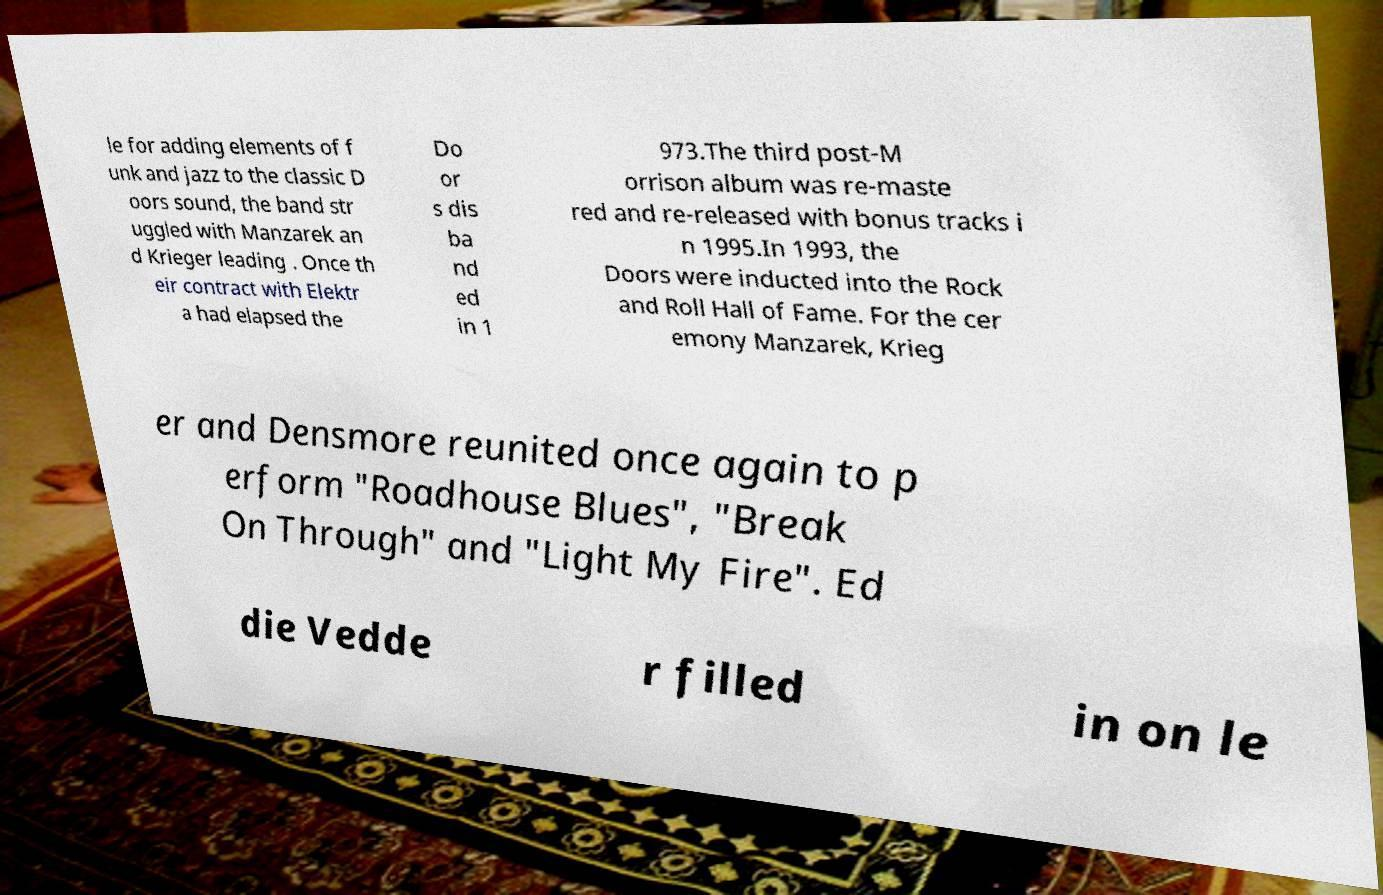Could you extract and type out the text from this image? le for adding elements of f unk and jazz to the classic D oors sound, the band str uggled with Manzarek an d Krieger leading . Once th eir contract with Elektr a had elapsed the Do or s dis ba nd ed in 1 973.The third post-M orrison album was re-maste red and re-released with bonus tracks i n 1995.In 1993, the Doors were inducted into the Rock and Roll Hall of Fame. For the cer emony Manzarek, Krieg er and Densmore reunited once again to p erform "Roadhouse Blues", "Break On Through" and "Light My Fire". Ed die Vedde r filled in on le 